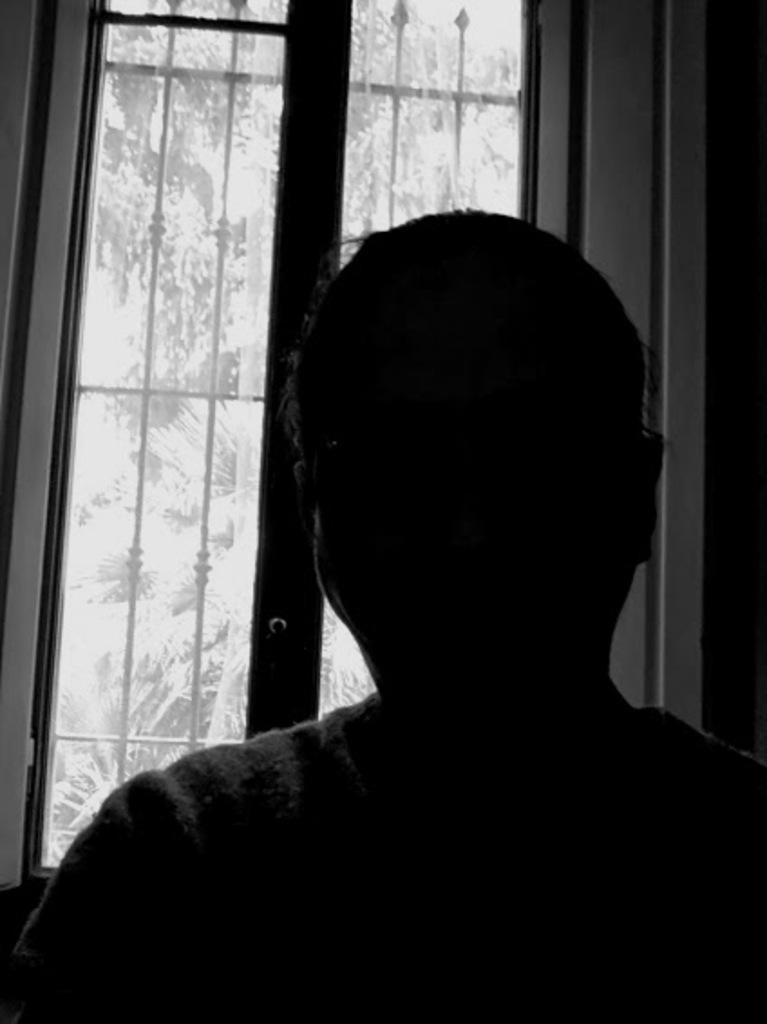Who or what is present in the image? There is a person in the image. What can be seen in the background of the image? There is a window in the image, and trees are visible through the window. What type of comb is being used by the person in the image? There is no comb visible in the image, and the person's actions are not described. 